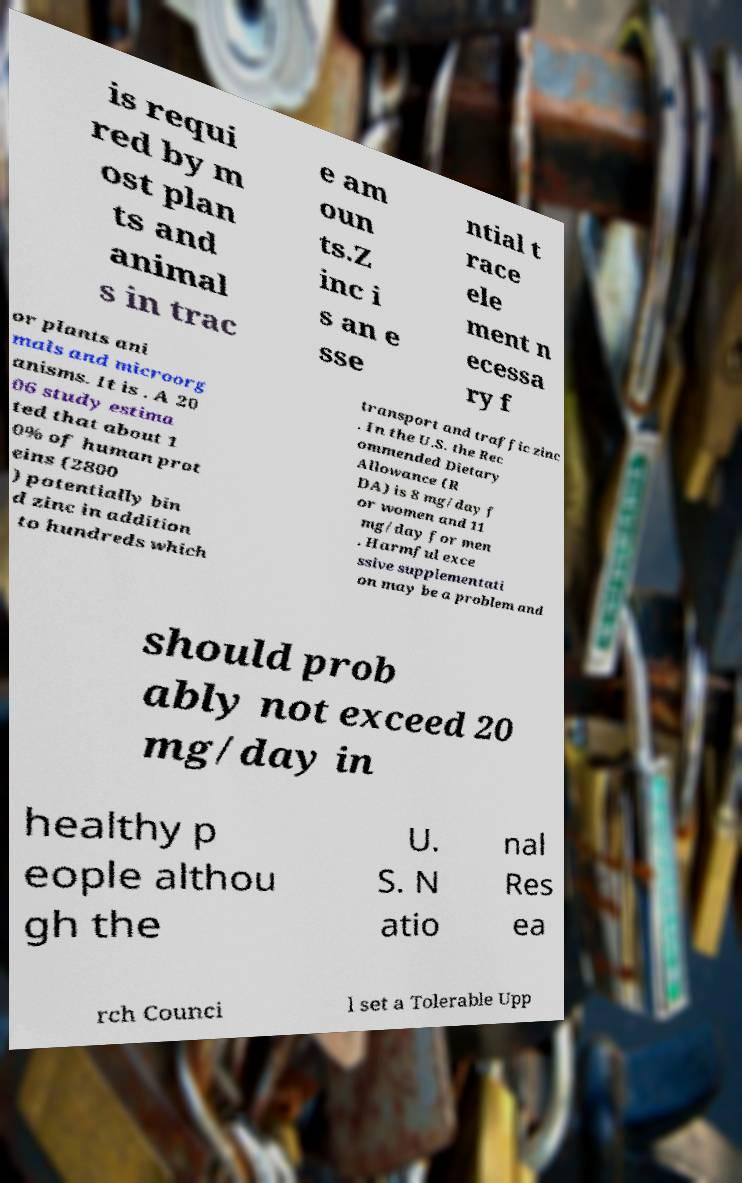Please read and relay the text visible in this image. What does it say? is requi red by m ost plan ts and animal s in trac e am oun ts.Z inc i s an e sse ntial t race ele ment n ecessa ry f or plants ani mals and microorg anisms. It is . A 20 06 study estima ted that about 1 0% of human prot eins (2800 ) potentially bin d zinc in addition to hundreds which transport and traffic zinc . In the U.S. the Rec ommended Dietary Allowance (R DA) is 8 mg/day f or women and 11 mg/day for men . Harmful exce ssive supplementati on may be a problem and should prob ably not exceed 20 mg/day in healthy p eople althou gh the U. S. N atio nal Res ea rch Counci l set a Tolerable Upp 